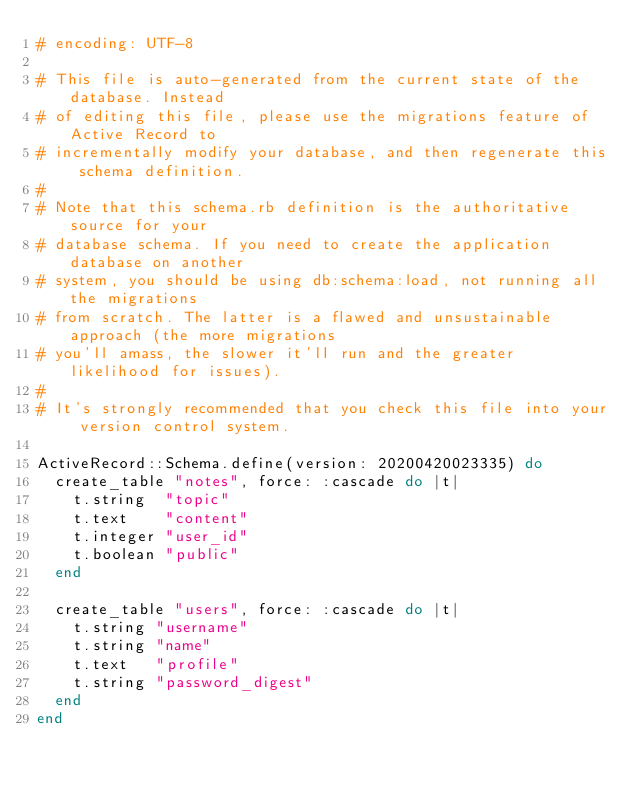Convert code to text. <code><loc_0><loc_0><loc_500><loc_500><_Ruby_># encoding: UTF-8

# This file is auto-generated from the current state of the database. Instead
# of editing this file, please use the migrations feature of Active Record to
# incrementally modify your database, and then regenerate this schema definition.
#
# Note that this schema.rb definition is the authoritative source for your
# database schema. If you need to create the application database on another
# system, you should be using db:schema:load, not running all the migrations
# from scratch. The latter is a flawed and unsustainable approach (the more migrations
# you'll amass, the slower it'll run and the greater likelihood for issues).
#
# It's strongly recommended that you check this file into your version control system.

ActiveRecord::Schema.define(version: 20200420023335) do
  create_table "notes", force: :cascade do |t|
    t.string  "topic"
    t.text    "content"
    t.integer "user_id"
    t.boolean "public"
  end

  create_table "users", force: :cascade do |t|
    t.string "username"
    t.string "name"
    t.text   "profile"
    t.string "password_digest"
  end
end
</code> 